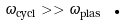<formula> <loc_0><loc_0><loc_500><loc_500>\omega _ { \text {cycl} } > > \omega _ { \text {plas} } \text { .}</formula> 